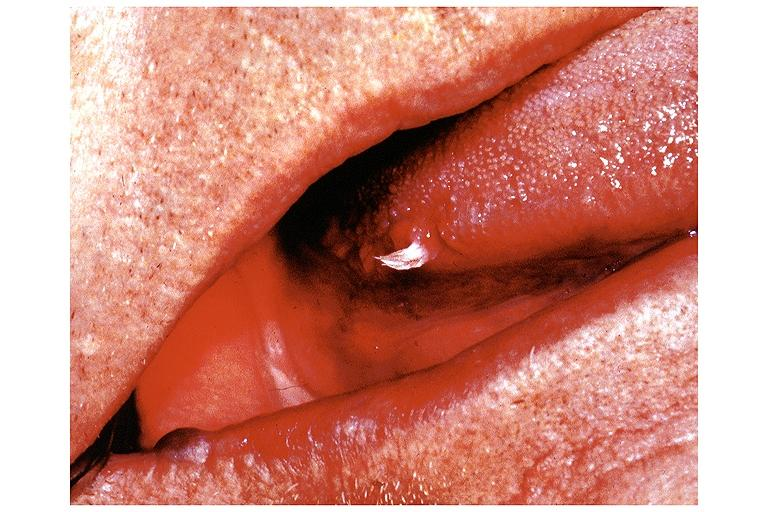s oral present?
Answer the question using a single word or phrase. Yes 